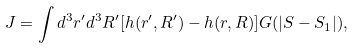<formula> <loc_0><loc_0><loc_500><loc_500>J = \int d ^ { 3 } r ^ { \prime } d ^ { 3 } R ^ { \prime } [ h ( { r } ^ { \prime } , { R } ^ { \prime } ) - h ( { r } , { R } ) ] G ( | S - S _ { 1 } | ) ,</formula> 